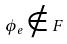Convert formula to latex. <formula><loc_0><loc_0><loc_500><loc_500>\phi _ { e } \notin F</formula> 